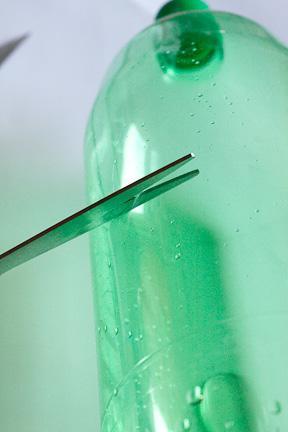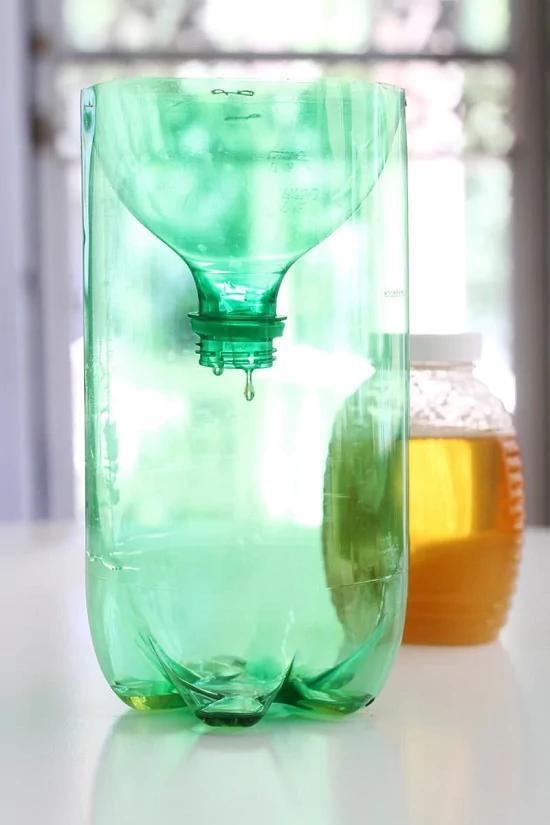The first image is the image on the left, the second image is the image on the right. Examine the images to the left and right. Is the description "The top of the bottle is sitting next to the bottom in one of the images." accurate? Answer yes or no. No. The first image is the image on the left, the second image is the image on the right. Evaluate the accuracy of this statement regarding the images: "In at least one image there is a green soda bottle cut in to two pieces.". Is it true? Answer yes or no. Yes. 